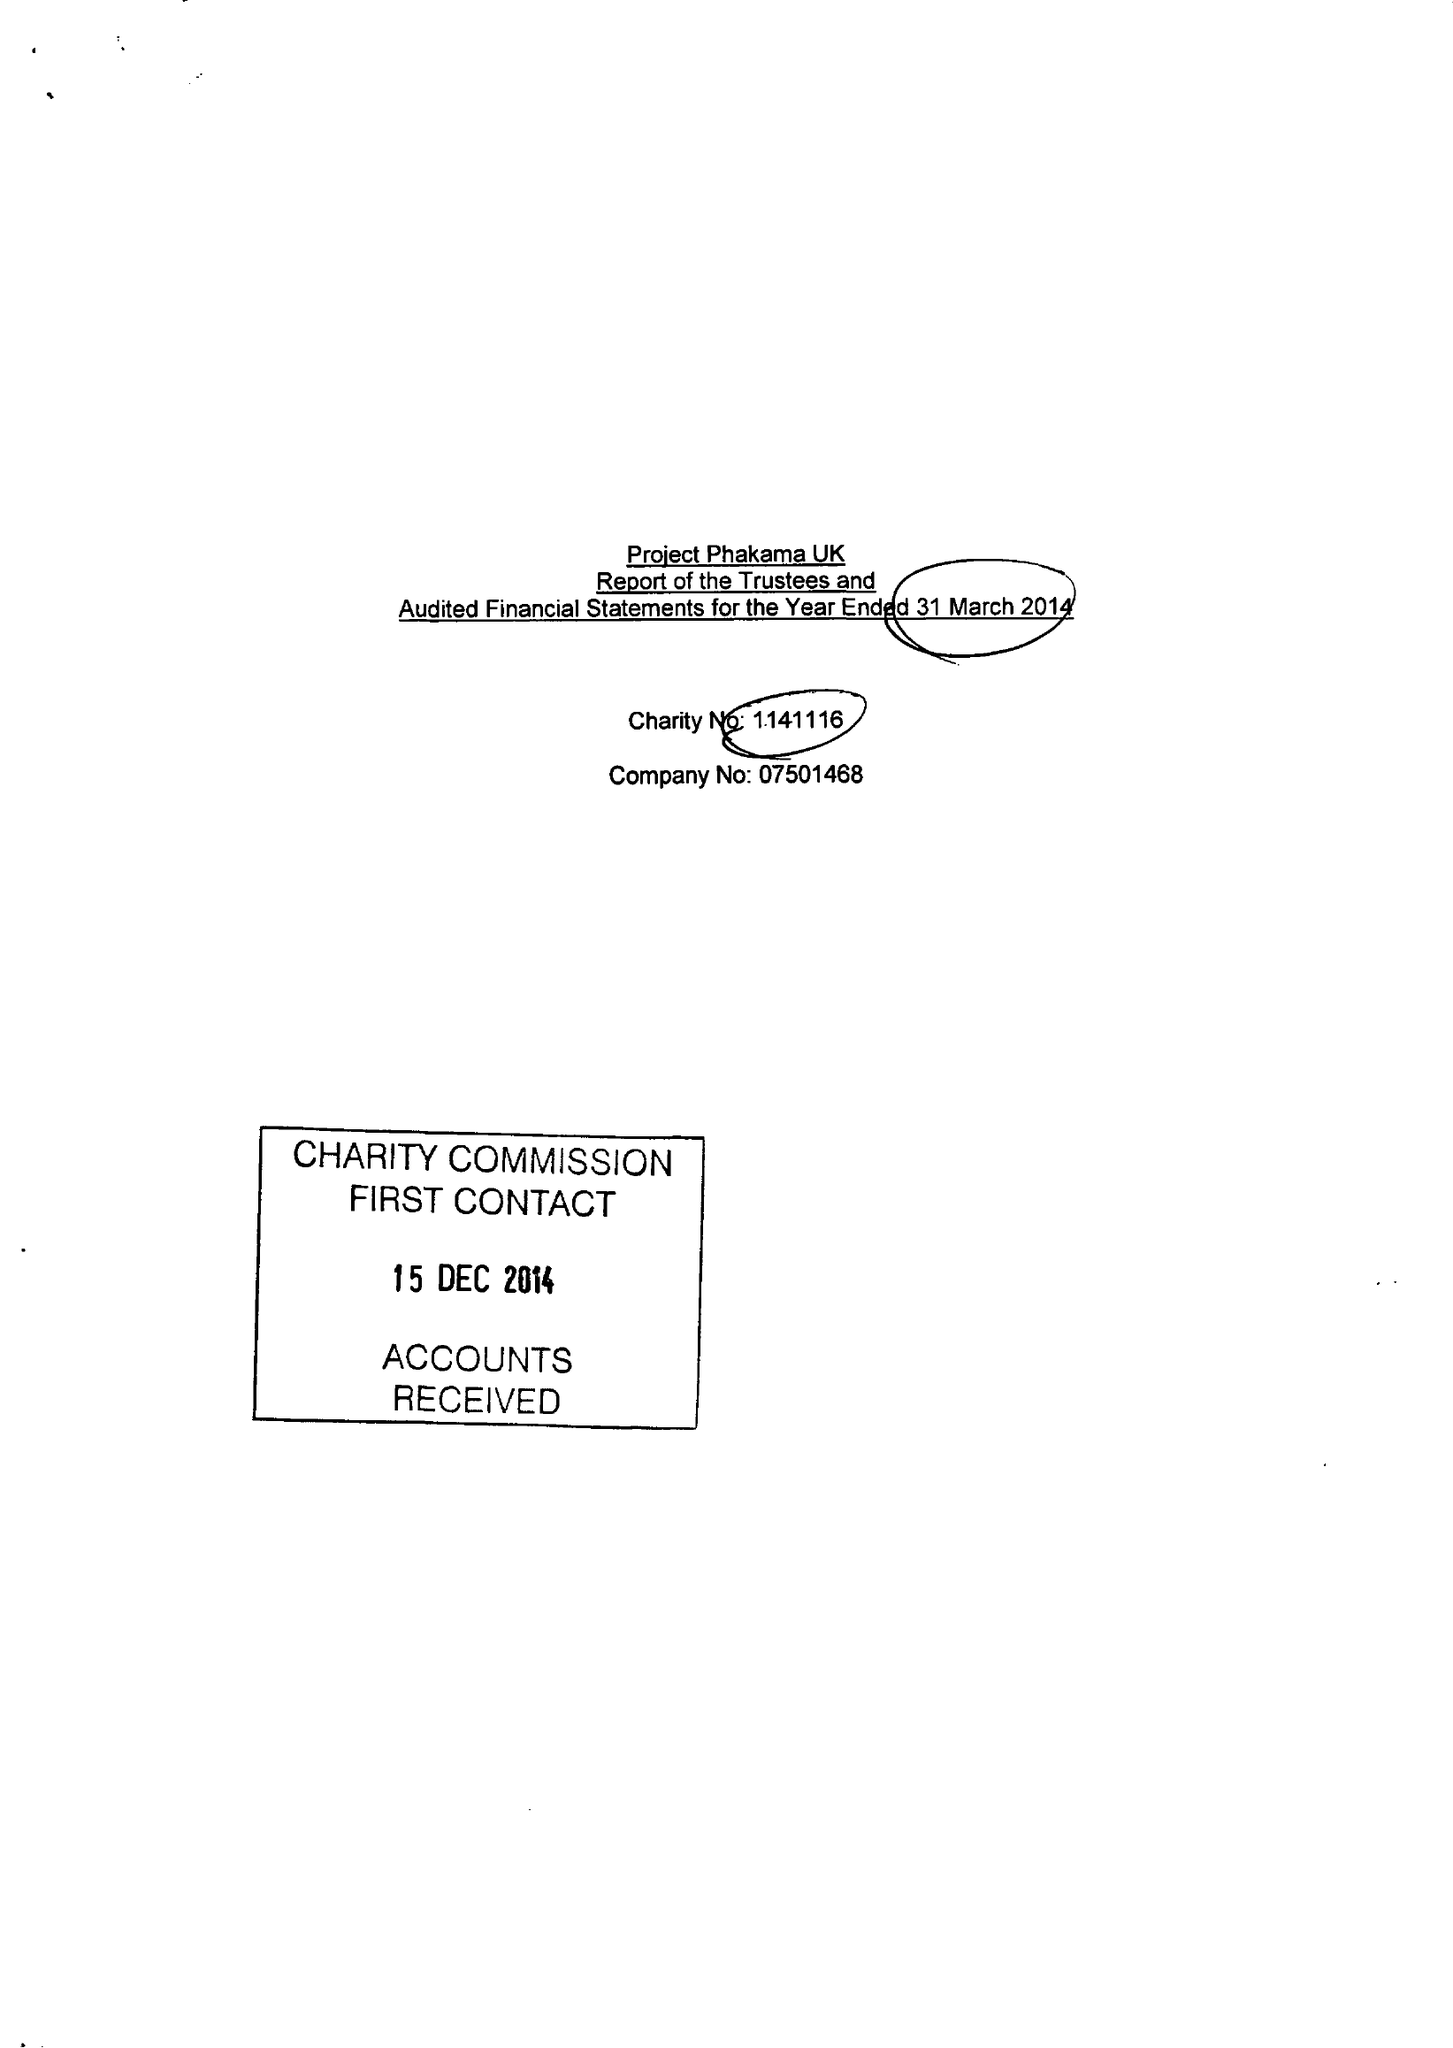What is the value for the charity_name?
Answer the question using a single word or phrase. Project Phakama Uk 